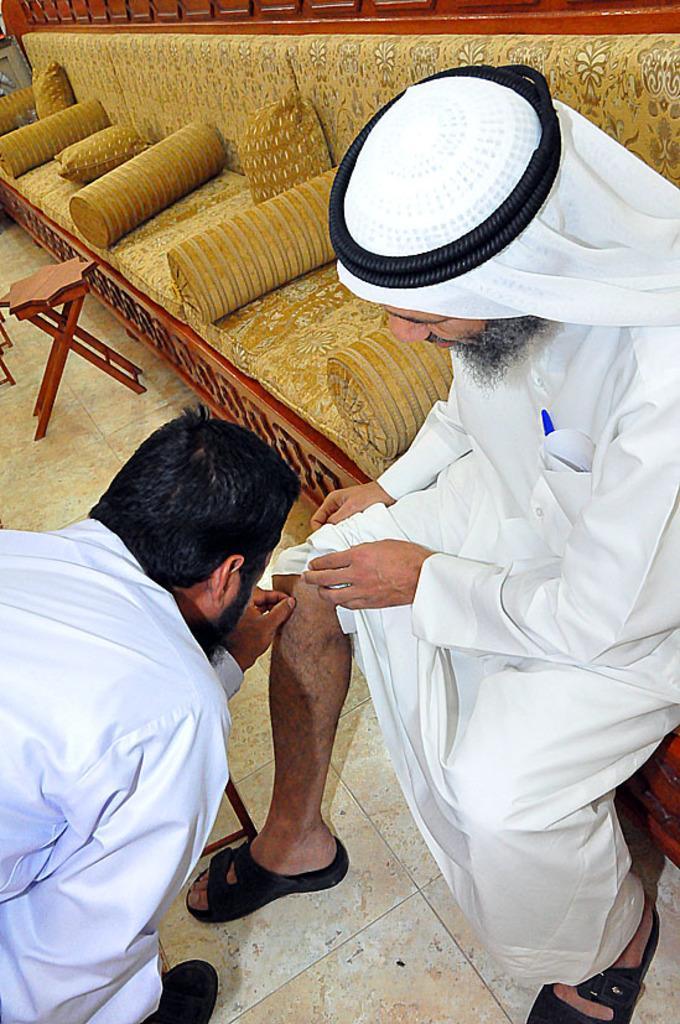Can you describe this image briefly? In the picture we can see a long sofa with some pillows and round pillows and a man sitting on it wearing a white color dress with a black color cloth on his head with a black color band in it and near to him we can see another man standing and bending and touching the leg of the person who is sitting and near to the sofa we can see a stool which is brown in color. 